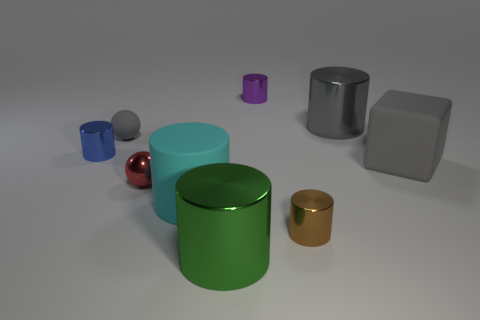What time of day does the lighting suggest in this scene? The lighting in the image seems diffused and soft, lacking strong shadows or highlights that would be typical of direct sunlight. This suggests an overcast day or indoor lighting where the sources of light are not directly visible, diffusing evenly across the scene. 